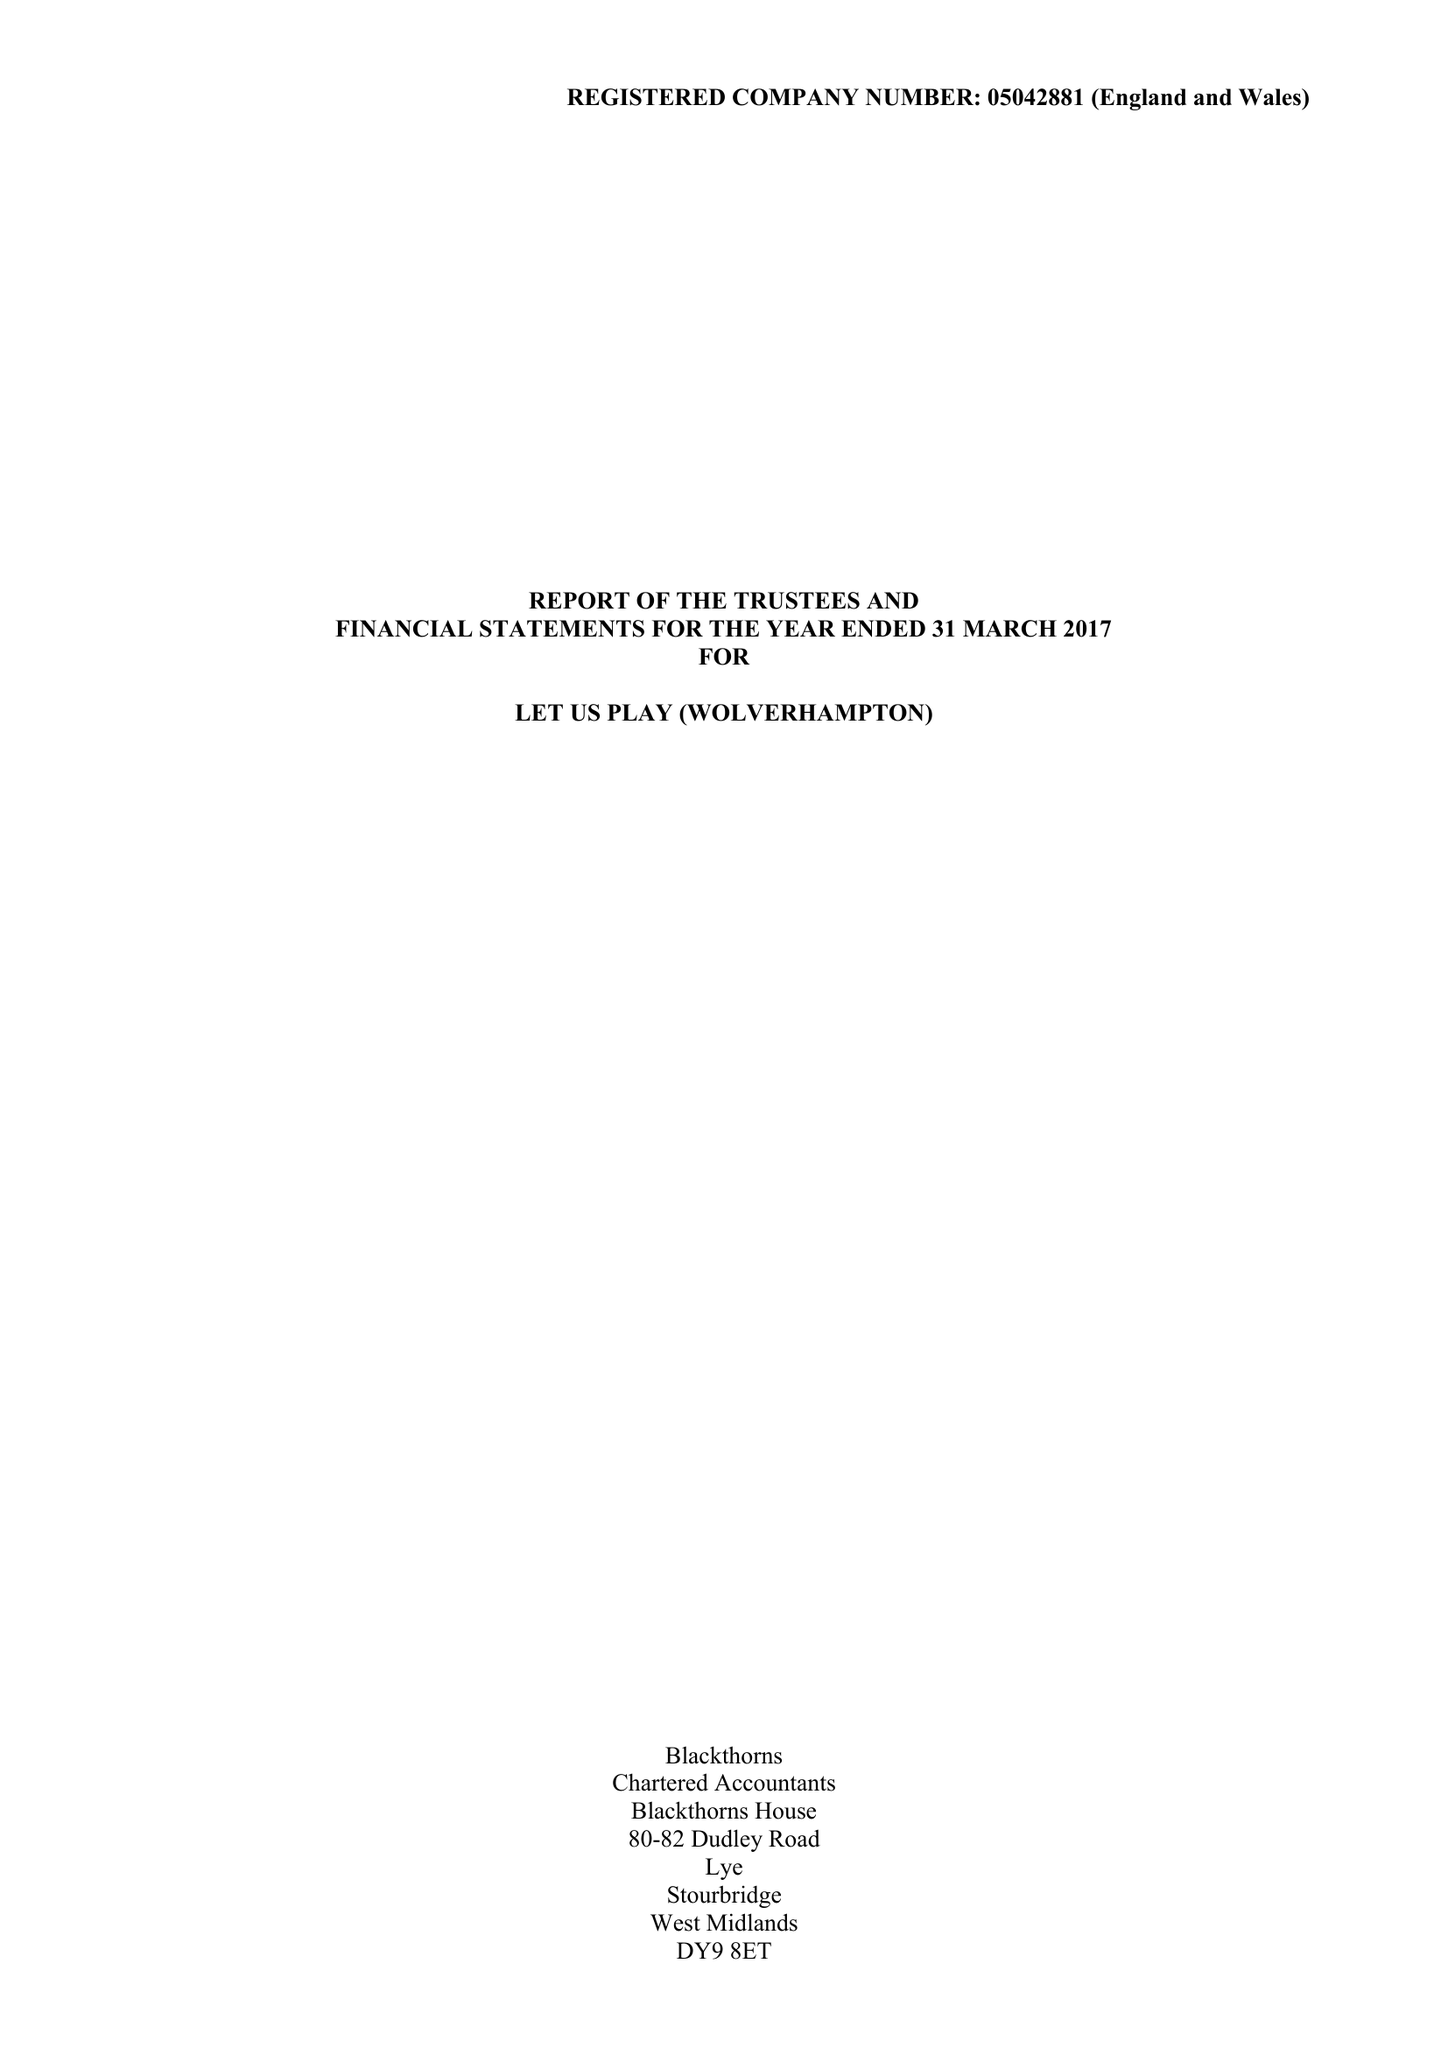What is the value for the spending_annually_in_british_pounds?
Answer the question using a single word or phrase. 94063.00 